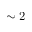Convert formula to latex. <formula><loc_0><loc_0><loc_500><loc_500>\sim 2</formula> 